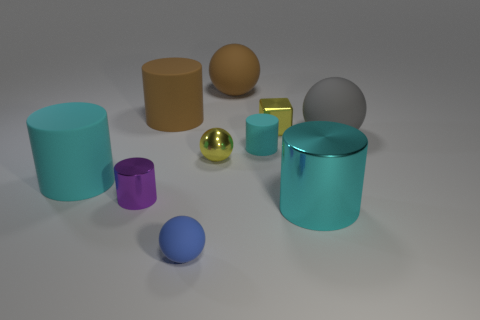Subtract all cyan blocks. How many cyan cylinders are left? 3 Subtract all brown cylinders. How many cylinders are left? 4 Subtract 1 spheres. How many spheres are left? 3 Subtract all tiny purple cylinders. How many cylinders are left? 4 Subtract all blue cylinders. Subtract all purple blocks. How many cylinders are left? 5 Subtract all blocks. How many objects are left? 9 Subtract 1 yellow cubes. How many objects are left? 9 Subtract all brown rubber balls. Subtract all big gray objects. How many objects are left? 8 Add 4 cylinders. How many cylinders are left? 9 Add 5 big gray rubber spheres. How many big gray rubber spheres exist? 6 